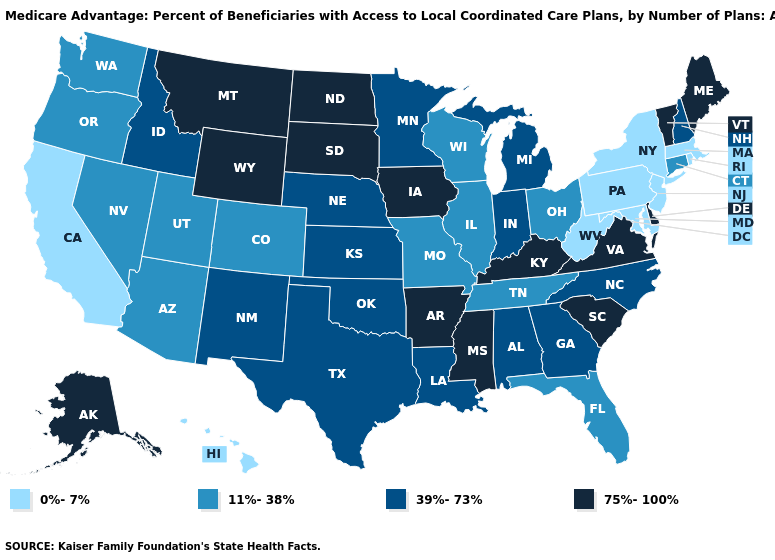Which states have the highest value in the USA?
Be succinct. Alaska, Arkansas, Delaware, Iowa, Kentucky, Maine, Mississippi, Montana, North Dakota, South Carolina, South Dakota, Virginia, Vermont, Wyoming. Name the states that have a value in the range 39%-73%?
Short answer required. Alabama, Georgia, Idaho, Indiana, Kansas, Louisiana, Michigan, Minnesota, North Carolina, Nebraska, New Hampshire, New Mexico, Oklahoma, Texas. Among the states that border Oklahoma , does Missouri have the lowest value?
Concise answer only. Yes. Name the states that have a value in the range 0%-7%?
Short answer required. California, Hawaii, Massachusetts, Maryland, New Jersey, New York, Pennsylvania, Rhode Island, West Virginia. Name the states that have a value in the range 0%-7%?
Keep it brief. California, Hawaii, Massachusetts, Maryland, New Jersey, New York, Pennsylvania, Rhode Island, West Virginia. What is the highest value in the USA?
Give a very brief answer. 75%-100%. Among the states that border Florida , which have the highest value?
Keep it brief. Alabama, Georgia. Name the states that have a value in the range 11%-38%?
Answer briefly. Arizona, Colorado, Connecticut, Florida, Illinois, Missouri, Nevada, Ohio, Oregon, Tennessee, Utah, Washington, Wisconsin. What is the lowest value in the Northeast?
Quick response, please. 0%-7%. What is the value of South Carolina?
Give a very brief answer. 75%-100%. Name the states that have a value in the range 75%-100%?
Concise answer only. Alaska, Arkansas, Delaware, Iowa, Kentucky, Maine, Mississippi, Montana, North Dakota, South Carolina, South Dakota, Virginia, Vermont, Wyoming. Among the states that border Nevada , which have the lowest value?
Quick response, please. California. What is the value of Georgia?
Write a very short answer. 39%-73%. Does New Mexico have the lowest value in the West?
Write a very short answer. No. What is the highest value in the Northeast ?
Concise answer only. 75%-100%. 